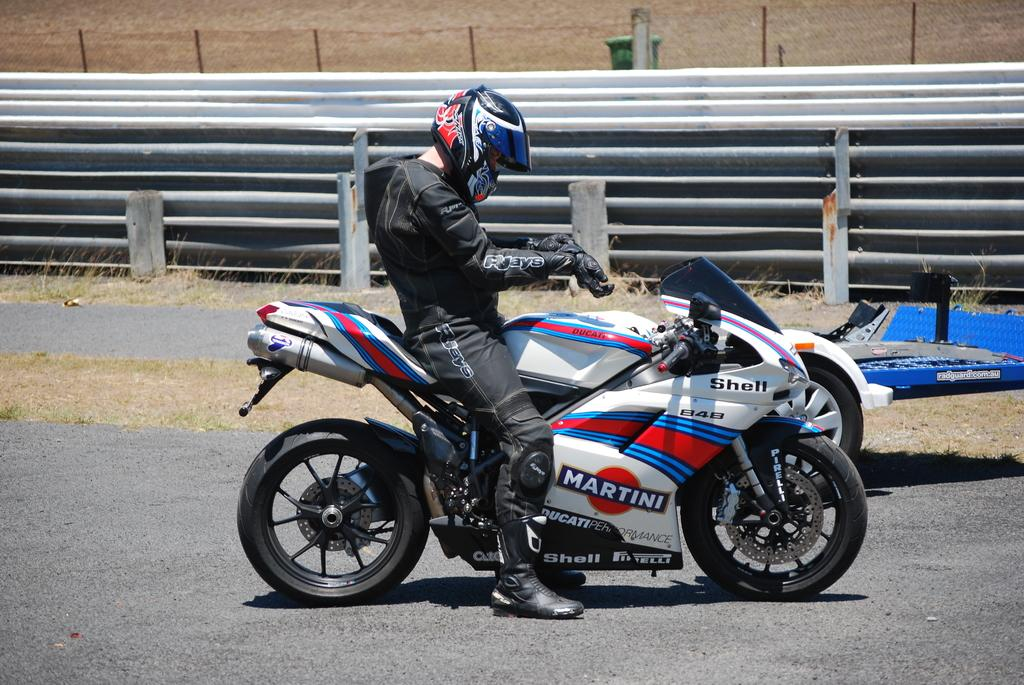What is the person in the image doing? There is a person sitting on a bike in the image. Where is the image taken? The image appears to be taken on a road. What can be seen in the background of the image? There is a fence, grass, and a pole in the background of the image. What type of paste is being used to hold the cable in the image? There is no cable or paste present in the image. What kind of cart is visible in the background of the image? There is no cart visible in the background of the image. 